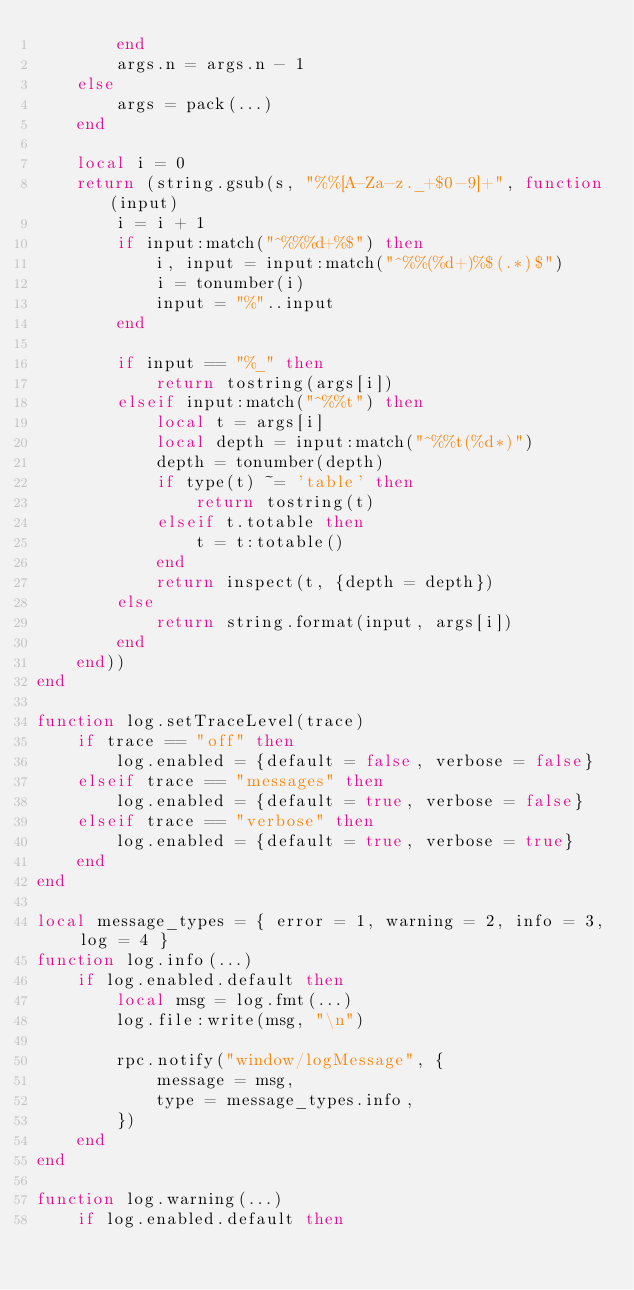Convert code to text. <code><loc_0><loc_0><loc_500><loc_500><_Lua_>		end
		args.n = args.n - 1
	else
		args = pack(...)
	end

	local i = 0
	return (string.gsub(s, "%%[A-Za-z._+$0-9]+", function(input)
		i = i + 1
		if input:match("^%%%d+%$") then
			i, input = input:match("^%%(%d+)%$(.*)$")
			i = tonumber(i)
			input = "%"..input
		end

		if input == "%_" then
			return tostring(args[i])
		elseif input:match("^%%t") then
			local t = args[i]
			local depth = input:match("^%%t(%d*)")
			depth = tonumber(depth)
			if type(t) ~= 'table' then
				return tostring(t)
			elseif t.totable then
				t = t:totable()
			end
			return inspect(t, {depth = depth})
		else
			return string.format(input, args[i])
		end
	end))
end

function log.setTraceLevel(trace)
	if trace == "off" then
		log.enabled = {default = false, verbose = false}
	elseif trace == "messages" then
		log.enabled = {default = true, verbose = false}
	elseif trace == "verbose" then
		log.enabled = {default = true, verbose = true}
	end
end

local message_types = { error = 1, warning = 2, info = 3, log = 4 }
function log.info(...)
	if log.enabled.default then
		local msg = log.fmt(...)
		log.file:write(msg, "\n")

		rpc.notify("window/logMessage", {
			message = msg,
			type = message_types.info,
		})
	end
end

function log.warning(...)
	if log.enabled.default then</code> 